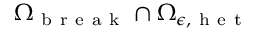Convert formula to latex. <formula><loc_0><loc_0><loc_500><loc_500>{ \Omega } _ { b r e a k } \cap { \Omega } _ { \epsilon , h e t }</formula> 